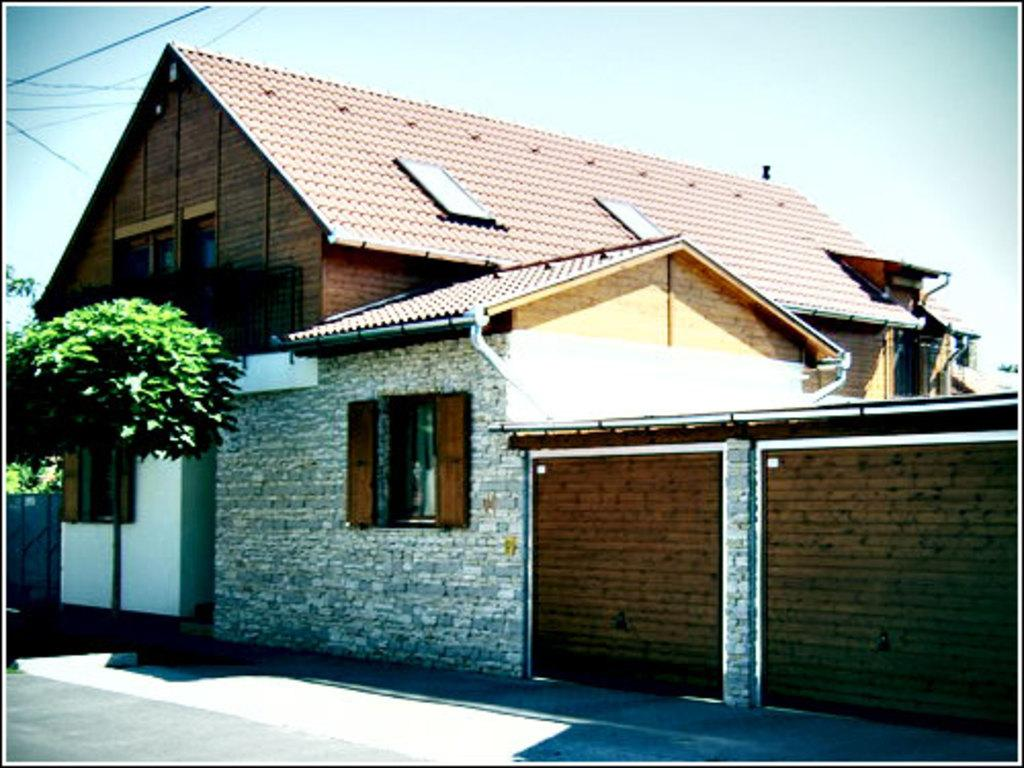What type of structure is visible in the image? There is a house in the image. What natural element is present in the image? There is a tree in the image. What can be seen at the bottom of the image? The bottom of the image contains a road. How does the can digest the food in the image? There is no can present in the image, and therefore no digestion process can be observed. 